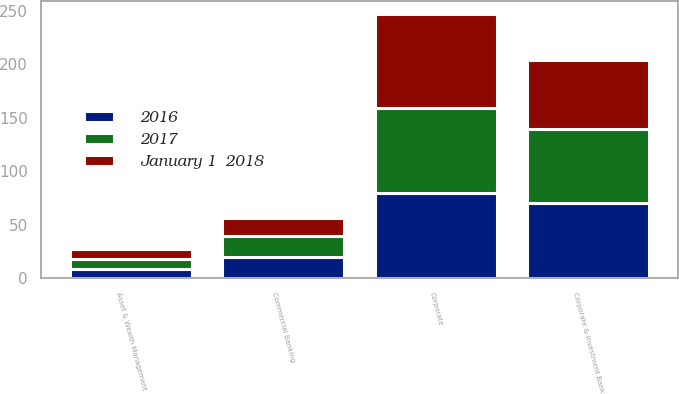Convert chart to OTSL. <chart><loc_0><loc_0><loc_500><loc_500><stacked_bar_chart><ecel><fcel>Corporate & Investment Bank<fcel>Commercial Banking<fcel>Asset & Wealth Management<fcel>Corporate<nl><fcel>2017<fcel>70<fcel>20<fcel>9<fcel>79.6<nl><fcel>2016<fcel>70<fcel>20<fcel>9<fcel>79.6<nl><fcel>January 1  2018<fcel>64<fcel>16<fcel>9<fcel>88.1<nl></chart> 